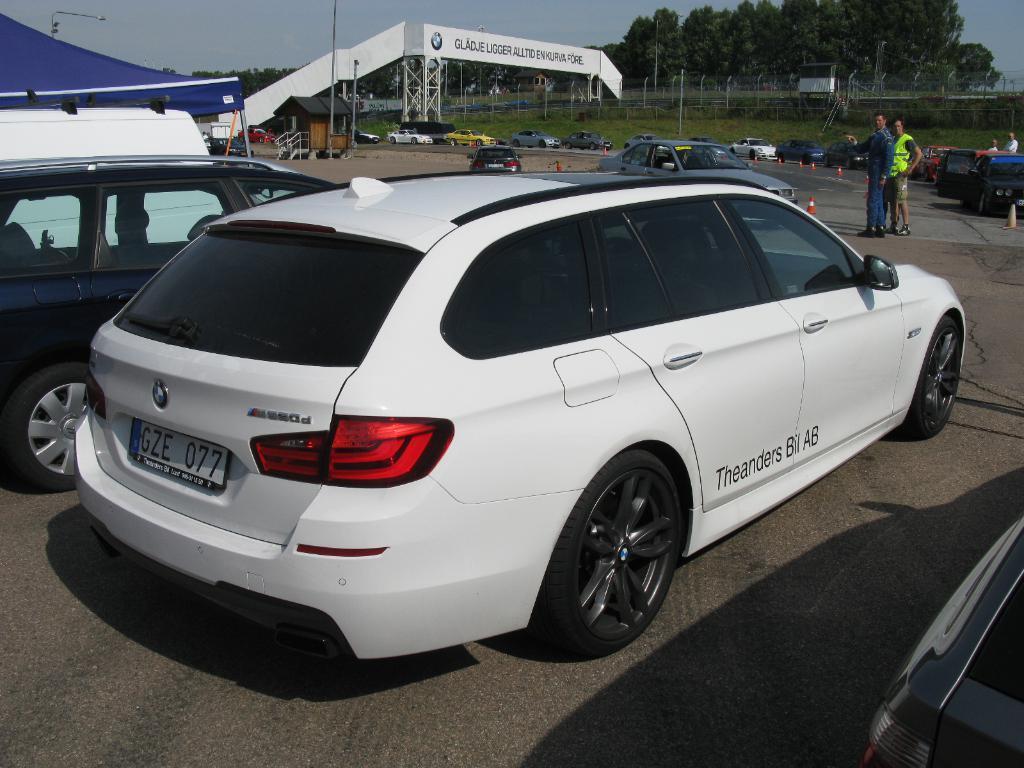Could you give a brief overview of what you see in this image? In this image we can see the vehicles. We can also see a tent for shelter. We can see the poles, board, rods and also the safety cones. We can also see the trees, grass and also the sky. We can see the house for shelter. At the bottom we can see the road. On the right we can see the people. 